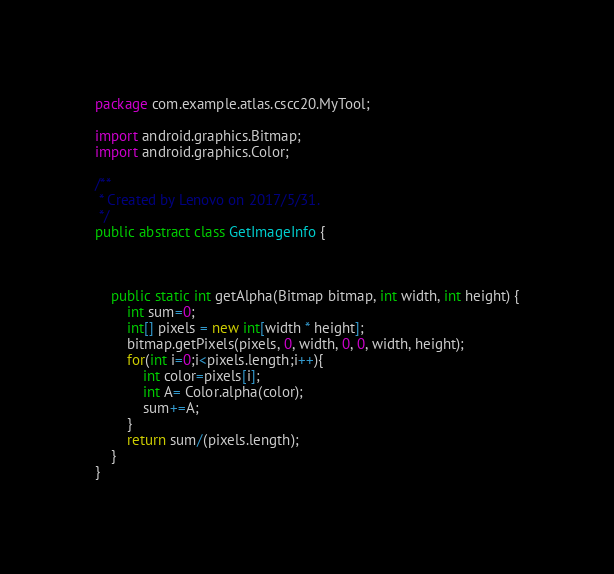Convert code to text. <code><loc_0><loc_0><loc_500><loc_500><_Java_>package com.example.atlas.cscc20.MyTool;

import android.graphics.Bitmap;
import android.graphics.Color;

/**
 * Created by Lenovo on 2017/5/31.
 */
public abstract class GetImageInfo {



    public static int getAlpha(Bitmap bitmap, int width, int height) {
        int sum=0;
        int[] pixels = new int[width * height];
        bitmap.getPixels(pixels, 0, width, 0, 0, width, height);
        for(int i=0;i<pixels.length;i++){
            int color=pixels[i];
            int A= Color.alpha(color);
            sum+=A;
        }
        return sum/(pixels.length);
    }
}</code> 